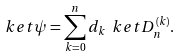Convert formula to latex. <formula><loc_0><loc_0><loc_500><loc_500>\ k e t { \psi } = \sum _ { k = 0 } ^ { n } d _ { k } \ k e t { D _ { n } ^ { ( k ) } } .</formula> 